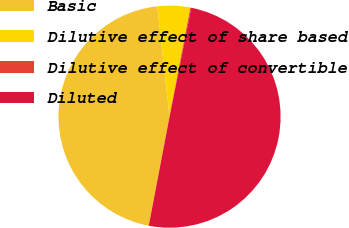<chart> <loc_0><loc_0><loc_500><loc_500><pie_chart><fcel>Basic<fcel>Dilutive effect of share based<fcel>Dilutive effect of convertible<fcel>Diluted<nl><fcel>45.24%<fcel>4.76%<fcel>0.14%<fcel>49.86%<nl></chart> 